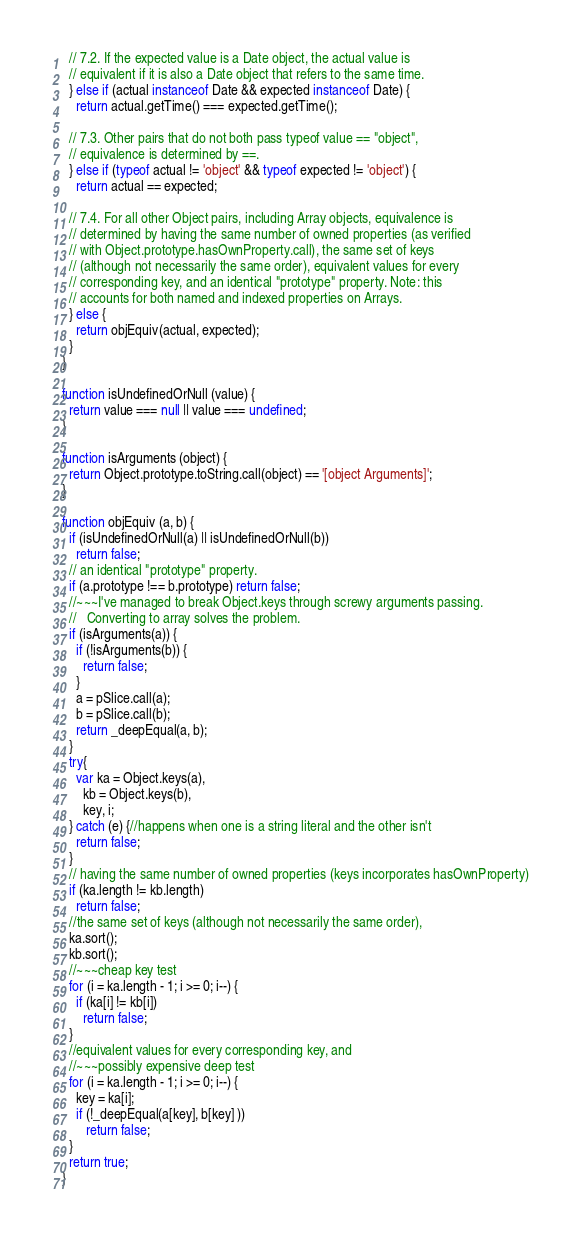<code> <loc_0><loc_0><loc_500><loc_500><_JavaScript_>  // 7.2. If the expected value is a Date object, the actual value is
  // equivalent if it is also a Date object that refers to the same time.
  } else if (actual instanceof Date && expected instanceof Date) {
    return actual.getTime() === expected.getTime();

  // 7.3. Other pairs that do not both pass typeof value == "object",
  // equivalence is determined by ==.
  } else if (typeof actual != 'object' && typeof expected != 'object') {
    return actual == expected;

  // 7.4. For all other Object pairs, including Array objects, equivalence is
  // determined by having the same number of owned properties (as verified
  // with Object.prototype.hasOwnProperty.call), the same set of keys
  // (although not necessarily the same order), equivalent values for every
  // corresponding key, and an identical "prototype" property. Note: this
  // accounts for both named and indexed properties on Arrays.
  } else {
    return objEquiv(actual, expected);
  }
}

function isUndefinedOrNull (value) {
  return value === null || value === undefined;
}

function isArguments (object) {
  return Object.prototype.toString.call(object) == '[object Arguments]';
}

function objEquiv (a, b) {
  if (isUndefinedOrNull(a) || isUndefinedOrNull(b))
    return false;
  // an identical "prototype" property.
  if (a.prototype !== b.prototype) return false;
  //~~~I've managed to break Object.keys through screwy arguments passing.
  //   Converting to array solves the problem.
  if (isArguments(a)) {
    if (!isArguments(b)) {
      return false;
    }
    a = pSlice.call(a);
    b = pSlice.call(b);
    return _deepEqual(a, b);
  }
  try{
    var ka = Object.keys(a),
      kb = Object.keys(b),
      key, i;
  } catch (e) {//happens when one is a string literal and the other isn't
    return false;
  }
  // having the same number of owned properties (keys incorporates hasOwnProperty)
  if (ka.length != kb.length)
    return false;
  //the same set of keys (although not necessarily the same order),
  ka.sort();
  kb.sort();
  //~~~cheap key test
  for (i = ka.length - 1; i >= 0; i--) {
    if (ka[i] != kb[i])
      return false;
  }
  //equivalent values for every corresponding key, and
  //~~~possibly expensive deep test
  for (i = ka.length - 1; i >= 0; i--) {
    key = ka[i];
    if (!_deepEqual(a[key], b[key] ))
       return false;
  }
  return true;
}
</code> 